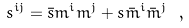Convert formula to latex. <formula><loc_0><loc_0><loc_500><loc_500>s ^ { i j } = { \bar { s } } m ^ { i } m ^ { j } + s { \bar { m } } ^ { i } { \bar { m } } ^ { j } \ ,</formula> 